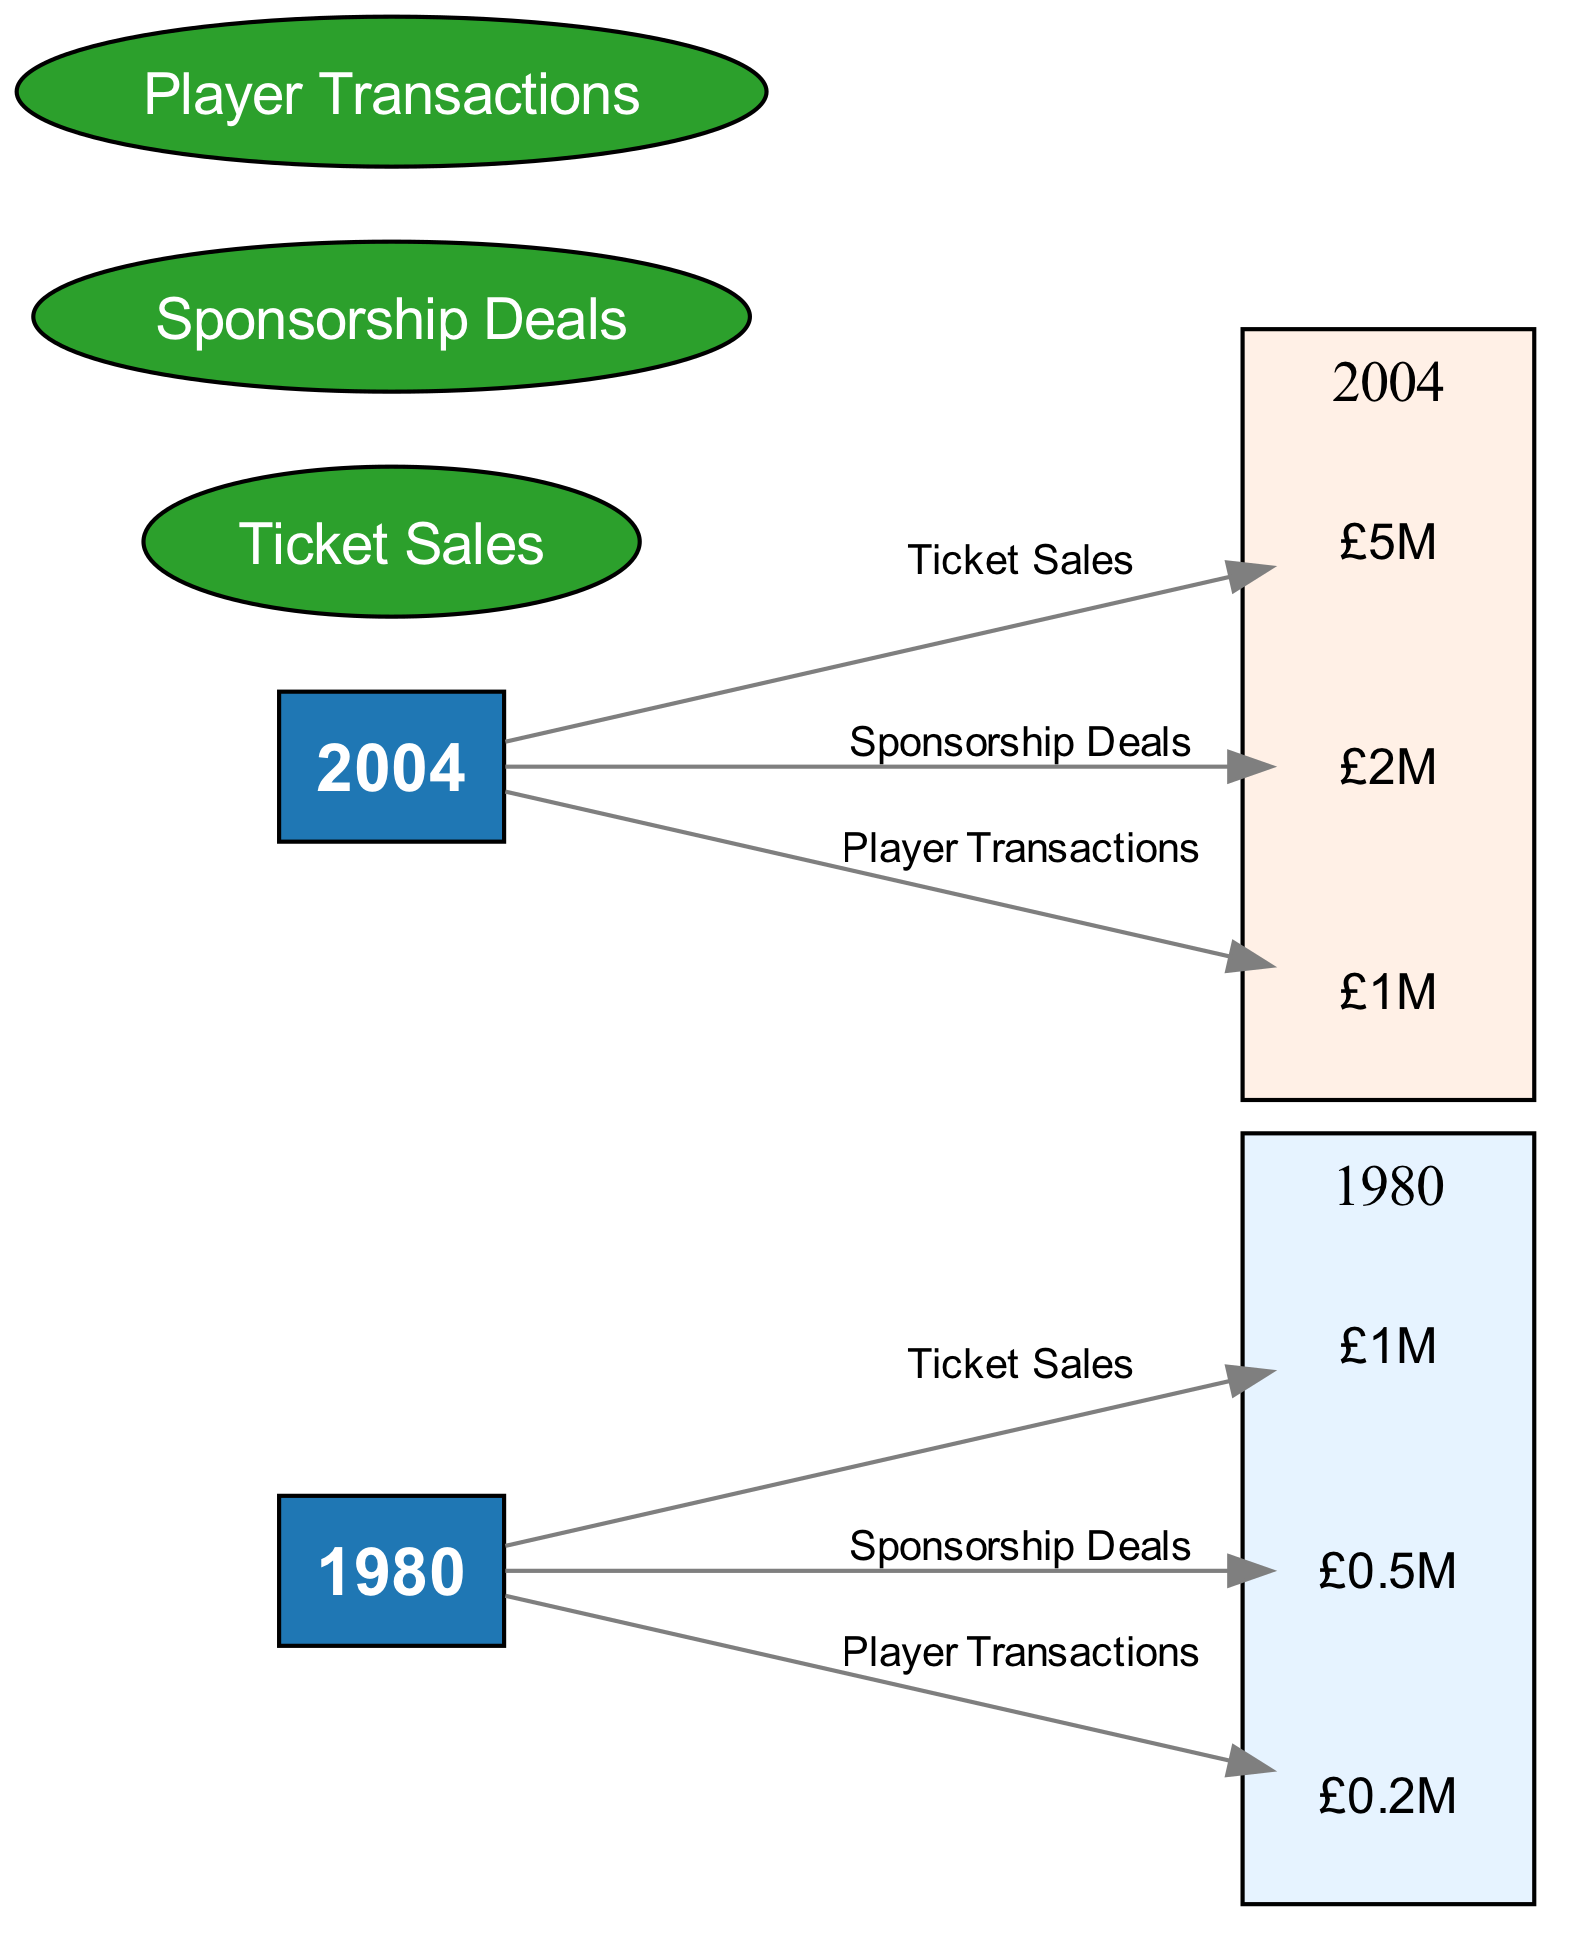What was the total ticket sales revenue for Wimbledon F.C. in 1980? The ticket sales revenue for Wimbledon F.C. in 1980 is specified as £1M in the diagram, represented in the node connected to the year node for 1980.
Answer: £1M How much revenue came from sponsorship deals in 2004? The diagram indicates the revenue from sponsorship deals for the year 2004 as £2M, which is shown in the corresponding revenue value node linked to the 2004 year node.
Answer: £2M What is the difference in ticket sales revenue from 1980 to 2004? In 1980, ticket sales revenue was £1M, and in 2004 it increased to £5M. The difference is calculated by subtracting 1980's revenue from 2004's revenue: £5M - £1M = £4M.
Answer: £4M How many revenue sources are represented in the diagram? The diagram includes three revenue sources: Ticket Sales, Sponsorship Deals, and Player Transactions. These can be counted directly in the revenue source nodes of the diagram.
Answer: 3 Which year had the highest revenue from player transactions and what was the value? The diagram shows that 2004 had the highest revenue from player transactions, amounting to £1M. This is identifiable in the 2004 player transactions node within the financial year cluster.
Answer: £1M What was the total revenue from all sources in 2004? In 2004, the total revenue comprises ticket sales (£5M), sponsorship deals (£2M), and player transactions (£1M). By adding these amounts together, £5M + £2M + £1M gives a total of £8M in 2004.
Answer: £8M Which revenue source saw the smallest revenue in 1980? The smallest revenue source in 1980 is from player transactions, which is represented as £0.2M in the diagram, indicating the lowest value among the three revenue sources for that year.
Answer: £0.2M How did sponsorship deals revenue change from 1980 to 2004? The diagram states that revenue from sponsorship deals in 1980 was £0.5M and increased to £2M in 2004. Thus, the change can be computed as an increase of £2M - £0.5M = £1.5M from 1980 to 2004.
Answer: £1.5M What type of diagram is used for this financial analysis? The diagram presents a financial analysis of Wimbledon F.C. using a Textbook Diagram format, which organizes information into nodes and edges representing the financial data visually.
Answer: Textbook Diagram 